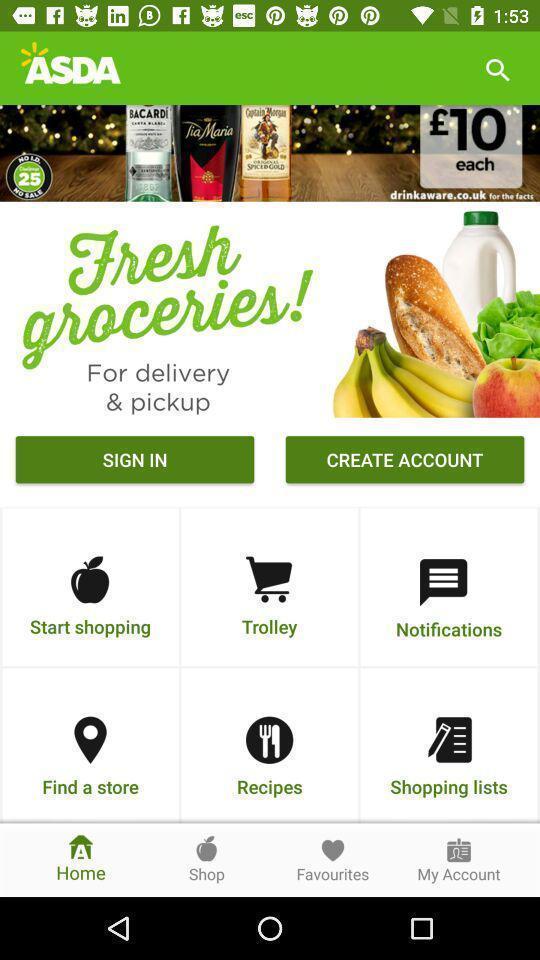Tell me what you see in this picture. Sign in page of a shopping application. 